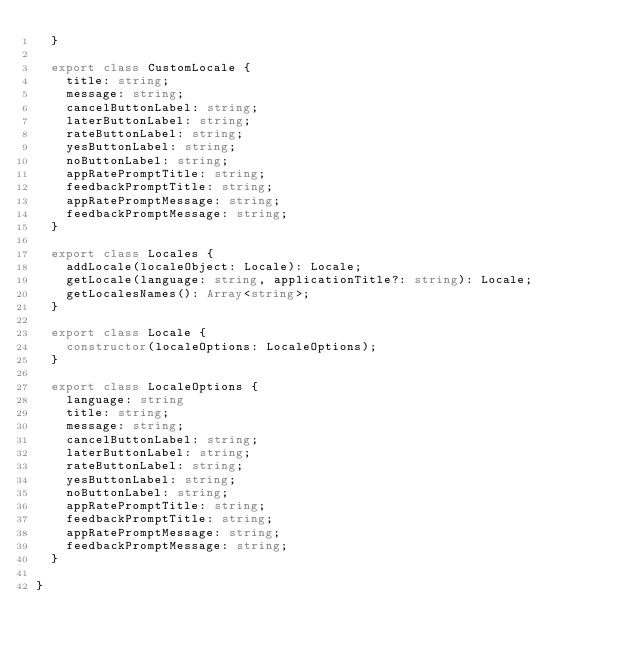<code> <loc_0><loc_0><loc_500><loc_500><_TypeScript_>  }

  export class CustomLocale {
    title: string;
    message: string;
    cancelButtonLabel: string;
    laterButtonLabel: string;
    rateButtonLabel: string;
    yesButtonLabel: string;
    noButtonLabel: string;
    appRatePromptTitle: string;
    feedbackPromptTitle: string;
    appRatePromptMessage: string;
    feedbackPromptMessage: string;
  }

  export class Locales {
    addLocale(localeObject: Locale): Locale;
    getLocale(language: string, applicationTitle?: string): Locale;
    getLocalesNames(): Array<string>;
  }

  export class Locale {
    constructor(localeOptions: LocaleOptions);
  }

  export class LocaleOptions {
    language: string
    title: string;
    message: string;
    cancelButtonLabel: string;
    laterButtonLabel: string;
    rateButtonLabel: string;
    yesButtonLabel: string;
    noButtonLabel: string;
    appRatePromptTitle: string;
    feedbackPromptTitle: string;
    appRatePromptMessage: string;
    feedbackPromptMessage: string;
  }
  
}
</code> 